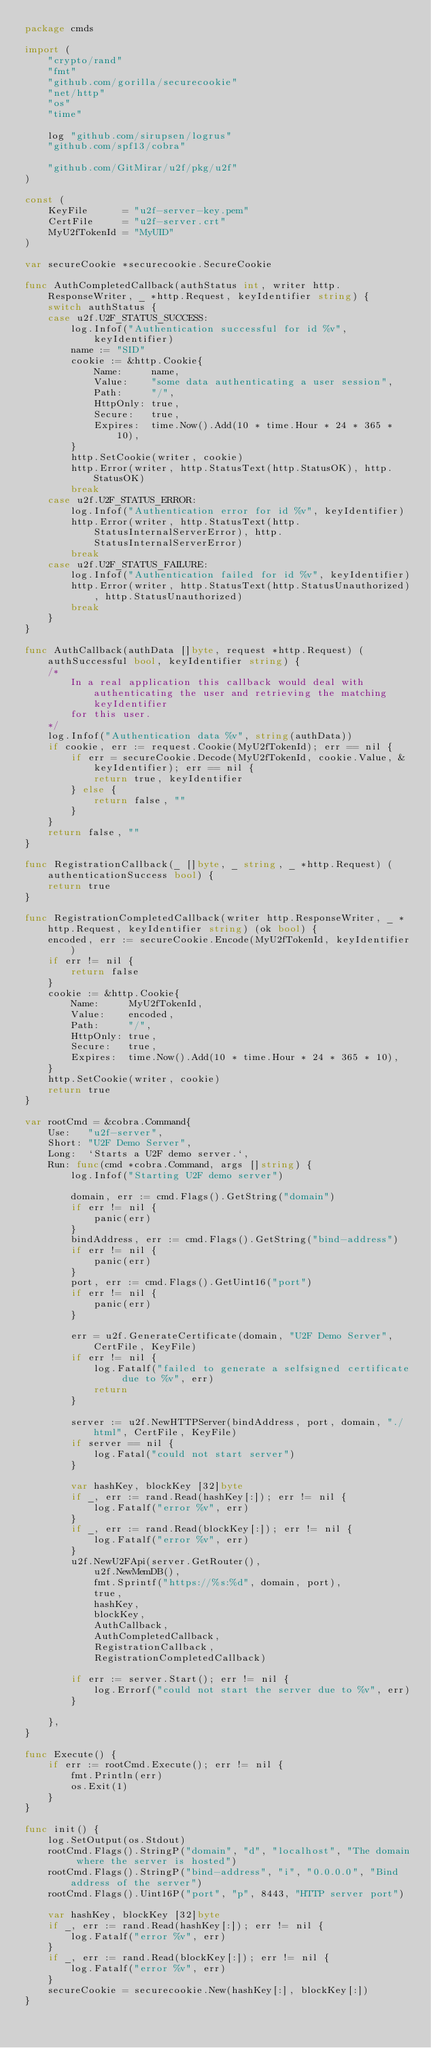<code> <loc_0><loc_0><loc_500><loc_500><_Go_>package cmds

import (
	"crypto/rand"
	"fmt"
	"github.com/gorilla/securecookie"
	"net/http"
	"os"
	"time"

	log "github.com/sirupsen/logrus"
	"github.com/spf13/cobra"

	"github.com/GitMirar/u2f/pkg/u2f"
)

const (
	KeyFile      = "u2f-server-key.pem"
	CertFile     = "u2f-server.crt"
	MyU2fTokenId = "MyUID"
)

var secureCookie *securecookie.SecureCookie

func AuthCompletedCallback(authStatus int, writer http.ResponseWriter, _ *http.Request, keyIdentifier string) {
	switch authStatus {
	case u2f.U2F_STATUS_SUCCESS:
		log.Infof("Authentication successful for id %v", keyIdentifier)
		name := "SID"
		cookie := &http.Cookie{
			Name:     name,
			Value:    "some data authenticating a user session",
			Path:     "/",
			HttpOnly: true,
			Secure:   true,
			Expires:  time.Now().Add(10 * time.Hour * 24 * 365 * 10),
		}
		http.SetCookie(writer, cookie)
		http.Error(writer, http.StatusText(http.StatusOK), http.StatusOK)
		break
	case u2f.U2F_STATUS_ERROR:
		log.Infof("Authentication error for id %v", keyIdentifier)
		http.Error(writer, http.StatusText(http.StatusInternalServerError), http.StatusInternalServerError)
		break
	case u2f.U2F_STATUS_FAILURE:
		log.Infof("Authentication failed for id %v", keyIdentifier)
		http.Error(writer, http.StatusText(http.StatusUnauthorized), http.StatusUnauthorized)
		break
	}
}

func AuthCallback(authData []byte, request *http.Request) (authSuccessful bool, keyIdentifier string) {
	/*
		In a real application this callback would deal with authenticating the user and retrieving the matching keyIdentifier
		for this user.
	*/
	log.Infof("Authentication data %v", string(authData))
	if cookie, err := request.Cookie(MyU2fTokenId); err == nil {
		if err = secureCookie.Decode(MyU2fTokenId, cookie.Value, &keyIdentifier); err == nil {
			return true, keyIdentifier
		} else {
			return false, ""
		}
	}
	return false, ""
}

func RegistrationCallback(_ []byte, _ string, _ *http.Request) (authenticationSuccess bool) {
	return true
}

func RegistrationCompletedCallback(writer http.ResponseWriter, _ *http.Request, keyIdentifier string) (ok bool) {
	encoded, err := secureCookie.Encode(MyU2fTokenId, keyIdentifier)
	if err != nil {
		return false
	}
	cookie := &http.Cookie{
		Name:     MyU2fTokenId,
		Value:    encoded,
		Path:     "/",
		HttpOnly: true,
		Secure:   true,
		Expires:  time.Now().Add(10 * time.Hour * 24 * 365 * 10),
	}
	http.SetCookie(writer, cookie)
	return true
}

var rootCmd = &cobra.Command{
	Use:   "u2f-server",
	Short: "U2F Demo Server",
	Long:  `Starts a U2F demo server.`,
	Run: func(cmd *cobra.Command, args []string) {
		log.Infof("Starting U2F demo server")

		domain, err := cmd.Flags().GetString("domain")
		if err != nil {
			panic(err)
		}
		bindAddress, err := cmd.Flags().GetString("bind-address")
		if err != nil {
			panic(err)
		}
		port, err := cmd.Flags().GetUint16("port")
		if err != nil {
			panic(err)
		}

		err = u2f.GenerateCertificate(domain, "U2F Demo Server", CertFile, KeyFile)
		if err != nil {
			log.Fatalf("failed to generate a selfsigned certificate due to %v", err)
			return
		}

		server := u2f.NewHTTPServer(bindAddress, port, domain, "./html", CertFile, KeyFile)
		if server == nil {
			log.Fatal("could not start server")
		}

		var hashKey, blockKey [32]byte
		if _, err := rand.Read(hashKey[:]); err != nil {
			log.Fatalf("error %v", err)
		}
		if _, err := rand.Read(blockKey[:]); err != nil {
			log.Fatalf("error %v", err)
		}
		u2f.NewU2FApi(server.GetRouter(),
			u2f.NewMemDB(),
			fmt.Sprintf("https://%s:%d", domain, port),
			true,
			hashKey,
			blockKey,
			AuthCallback,
			AuthCompletedCallback,
			RegistrationCallback,
			RegistrationCompletedCallback)

		if err := server.Start(); err != nil {
			log.Errorf("could not start the server due to %v", err)
		}

	},
}

func Execute() {
	if err := rootCmd.Execute(); err != nil {
		fmt.Println(err)
		os.Exit(1)
	}
}

func init() {
	log.SetOutput(os.Stdout)
	rootCmd.Flags().StringP("domain", "d", "localhost", "The domain where the server is hosted")
	rootCmd.Flags().StringP("bind-address", "i", "0.0.0.0", "Bind address of the server")
	rootCmd.Flags().Uint16P("port", "p", 8443, "HTTP server port")

	var hashKey, blockKey [32]byte
	if _, err := rand.Read(hashKey[:]); err != nil {
		log.Fatalf("error %v", err)
	}
	if _, err := rand.Read(blockKey[:]); err != nil {
		log.Fatalf("error %v", err)
	}
	secureCookie = securecookie.New(hashKey[:], blockKey[:])
}
</code> 